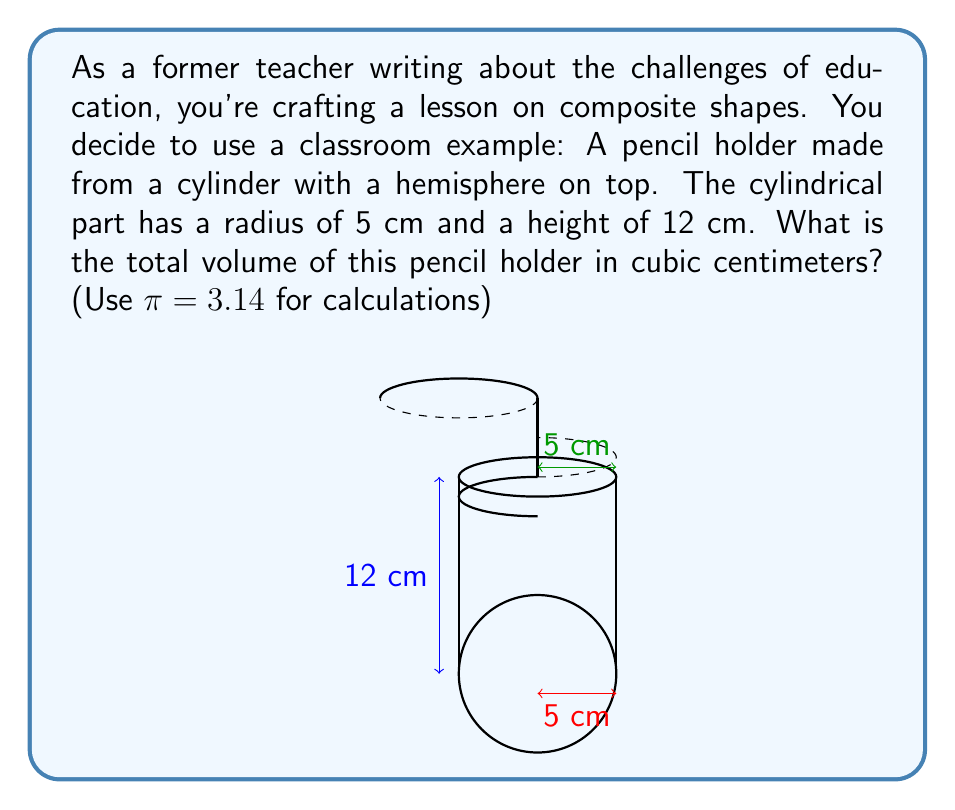Show me your answer to this math problem. To solve this problem, we need to calculate the volumes of both the cylindrical part and the hemispherical part, then add them together.

1. Volume of the cylinder:
   The formula for the volume of a cylinder is $V_{cylinder} = \pi r^2 h$
   Where $r$ is the radius and $h$ is the height.
   
   $$V_{cylinder} = \pi (5\text{ cm})^2 (12\text{ cm}) = 3.14 \times 25\text{ cm}^2 \times 12\text{ cm} = 942\text{ cm}^3$$

2. Volume of the hemisphere:
   The formula for the volume of a sphere is $V_{sphere} = \frac{4}{3}\pi r^3$
   A hemisphere is half of this, so we use $V_{hemisphere} = \frac{1}{2} \times \frac{4}{3}\pi r^3 = \frac{2}{3}\pi r^3$
   
   $$V_{hemisphere} = \frac{2}{3} \times 3.14 \times (5\text{ cm})^3 = \frac{2}{3} \times 3.14 \times 125\text{ cm}^3 = 261.67\text{ cm}^3$$

3. Total volume:
   Add the volumes of the cylinder and hemisphere:
   
   $$V_{total} = V_{cylinder} + V_{hemisphere} = 942\text{ cm}^3 + 261.67\text{ cm}^3 = 1203.67\text{ cm}^3$$

Rounding to the nearest whole number, we get 1204 cm³.
Answer: 1204 cm³ 